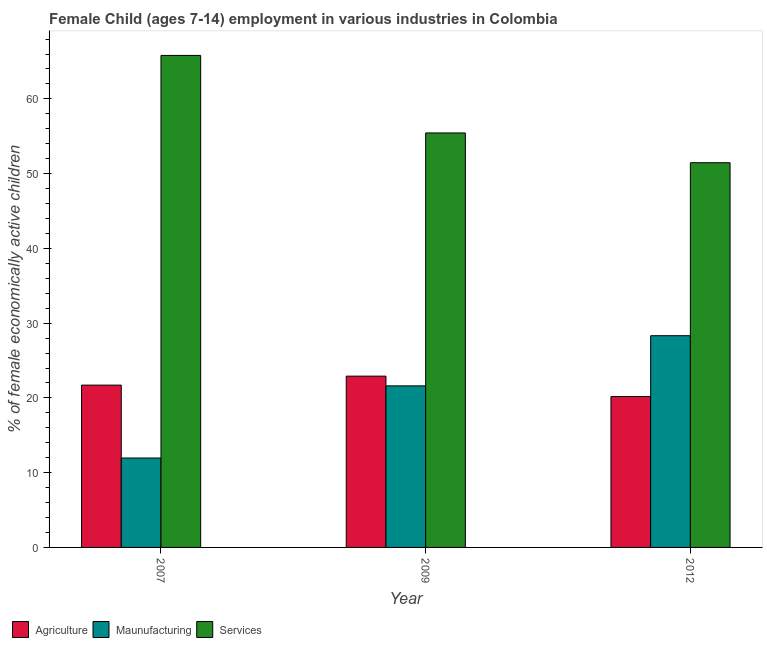How many different coloured bars are there?
Provide a succinct answer. 3. Are the number of bars per tick equal to the number of legend labels?
Your answer should be very brief. Yes. Are the number of bars on each tick of the X-axis equal?
Ensure brevity in your answer.  Yes. How many bars are there on the 1st tick from the left?
Your answer should be very brief. 3. How many bars are there on the 2nd tick from the right?
Make the answer very short. 3. In how many cases, is the number of bars for a given year not equal to the number of legend labels?
Ensure brevity in your answer.  0. What is the percentage of economically active children in services in 2007?
Keep it short and to the point. 65.81. Across all years, what is the maximum percentage of economically active children in manufacturing?
Ensure brevity in your answer.  28.32. Across all years, what is the minimum percentage of economically active children in agriculture?
Give a very brief answer. 20.18. What is the total percentage of economically active children in services in the graph?
Give a very brief answer. 172.71. What is the difference between the percentage of economically active children in agriculture in 2007 and that in 2009?
Keep it short and to the point. -1.2. What is the difference between the percentage of economically active children in manufacturing in 2012 and the percentage of economically active children in agriculture in 2009?
Your answer should be compact. 6.71. What is the average percentage of economically active children in services per year?
Give a very brief answer. 57.57. In the year 2007, what is the difference between the percentage of economically active children in services and percentage of economically active children in manufacturing?
Provide a short and direct response. 0. In how many years, is the percentage of economically active children in manufacturing greater than 56 %?
Provide a succinct answer. 0. What is the ratio of the percentage of economically active children in agriculture in 2007 to that in 2012?
Keep it short and to the point. 1.08. What is the difference between the highest and the second highest percentage of economically active children in services?
Give a very brief answer. 10.37. What is the difference between the highest and the lowest percentage of economically active children in manufacturing?
Your response must be concise. 16.36. What does the 1st bar from the left in 2012 represents?
Provide a short and direct response. Agriculture. What does the 2nd bar from the right in 2007 represents?
Provide a short and direct response. Maunufacturing. How many bars are there?
Make the answer very short. 9. Are all the bars in the graph horizontal?
Ensure brevity in your answer.  No. Are the values on the major ticks of Y-axis written in scientific E-notation?
Ensure brevity in your answer.  No. How many legend labels are there?
Your response must be concise. 3. What is the title of the graph?
Ensure brevity in your answer.  Female Child (ages 7-14) employment in various industries in Colombia. Does "Fuel" appear as one of the legend labels in the graph?
Your answer should be very brief. No. What is the label or title of the X-axis?
Offer a terse response. Year. What is the label or title of the Y-axis?
Keep it short and to the point. % of female economically active children. What is the % of female economically active children in Agriculture in 2007?
Provide a short and direct response. 21.71. What is the % of female economically active children in Maunufacturing in 2007?
Ensure brevity in your answer.  11.96. What is the % of female economically active children in Services in 2007?
Your response must be concise. 65.81. What is the % of female economically active children in Agriculture in 2009?
Offer a terse response. 22.91. What is the % of female economically active children of Maunufacturing in 2009?
Ensure brevity in your answer.  21.61. What is the % of female economically active children in Services in 2009?
Give a very brief answer. 55.44. What is the % of female economically active children of Agriculture in 2012?
Keep it short and to the point. 20.18. What is the % of female economically active children of Maunufacturing in 2012?
Provide a succinct answer. 28.32. What is the % of female economically active children of Services in 2012?
Give a very brief answer. 51.46. Across all years, what is the maximum % of female economically active children of Agriculture?
Your answer should be compact. 22.91. Across all years, what is the maximum % of female economically active children in Maunufacturing?
Offer a terse response. 28.32. Across all years, what is the maximum % of female economically active children of Services?
Make the answer very short. 65.81. Across all years, what is the minimum % of female economically active children in Agriculture?
Your answer should be compact. 20.18. Across all years, what is the minimum % of female economically active children of Maunufacturing?
Keep it short and to the point. 11.96. Across all years, what is the minimum % of female economically active children of Services?
Your response must be concise. 51.46. What is the total % of female economically active children in Agriculture in the graph?
Provide a short and direct response. 64.8. What is the total % of female economically active children of Maunufacturing in the graph?
Keep it short and to the point. 61.89. What is the total % of female economically active children of Services in the graph?
Your answer should be very brief. 172.71. What is the difference between the % of female economically active children of Agriculture in 2007 and that in 2009?
Ensure brevity in your answer.  -1.2. What is the difference between the % of female economically active children in Maunufacturing in 2007 and that in 2009?
Keep it short and to the point. -9.65. What is the difference between the % of female economically active children in Services in 2007 and that in 2009?
Offer a terse response. 10.37. What is the difference between the % of female economically active children in Agriculture in 2007 and that in 2012?
Provide a succinct answer. 1.53. What is the difference between the % of female economically active children in Maunufacturing in 2007 and that in 2012?
Give a very brief answer. -16.36. What is the difference between the % of female economically active children in Services in 2007 and that in 2012?
Offer a very short reply. 14.35. What is the difference between the % of female economically active children of Agriculture in 2009 and that in 2012?
Offer a very short reply. 2.73. What is the difference between the % of female economically active children of Maunufacturing in 2009 and that in 2012?
Your answer should be compact. -6.71. What is the difference between the % of female economically active children in Services in 2009 and that in 2012?
Your response must be concise. 3.98. What is the difference between the % of female economically active children in Agriculture in 2007 and the % of female economically active children in Services in 2009?
Ensure brevity in your answer.  -33.73. What is the difference between the % of female economically active children of Maunufacturing in 2007 and the % of female economically active children of Services in 2009?
Provide a short and direct response. -43.48. What is the difference between the % of female economically active children in Agriculture in 2007 and the % of female economically active children in Maunufacturing in 2012?
Your answer should be compact. -6.61. What is the difference between the % of female economically active children in Agriculture in 2007 and the % of female economically active children in Services in 2012?
Provide a short and direct response. -29.75. What is the difference between the % of female economically active children in Maunufacturing in 2007 and the % of female economically active children in Services in 2012?
Your answer should be compact. -39.5. What is the difference between the % of female economically active children of Agriculture in 2009 and the % of female economically active children of Maunufacturing in 2012?
Ensure brevity in your answer.  -5.41. What is the difference between the % of female economically active children of Agriculture in 2009 and the % of female economically active children of Services in 2012?
Give a very brief answer. -28.55. What is the difference between the % of female economically active children of Maunufacturing in 2009 and the % of female economically active children of Services in 2012?
Ensure brevity in your answer.  -29.85. What is the average % of female economically active children in Agriculture per year?
Provide a short and direct response. 21.6. What is the average % of female economically active children in Maunufacturing per year?
Provide a succinct answer. 20.63. What is the average % of female economically active children of Services per year?
Your response must be concise. 57.57. In the year 2007, what is the difference between the % of female economically active children in Agriculture and % of female economically active children in Maunufacturing?
Offer a terse response. 9.75. In the year 2007, what is the difference between the % of female economically active children in Agriculture and % of female economically active children in Services?
Provide a short and direct response. -44.1. In the year 2007, what is the difference between the % of female economically active children in Maunufacturing and % of female economically active children in Services?
Provide a succinct answer. -53.85. In the year 2009, what is the difference between the % of female economically active children of Agriculture and % of female economically active children of Maunufacturing?
Offer a terse response. 1.3. In the year 2009, what is the difference between the % of female economically active children of Agriculture and % of female economically active children of Services?
Provide a succinct answer. -32.53. In the year 2009, what is the difference between the % of female economically active children in Maunufacturing and % of female economically active children in Services?
Keep it short and to the point. -33.83. In the year 2012, what is the difference between the % of female economically active children in Agriculture and % of female economically active children in Maunufacturing?
Ensure brevity in your answer.  -8.14. In the year 2012, what is the difference between the % of female economically active children in Agriculture and % of female economically active children in Services?
Your answer should be very brief. -31.28. In the year 2012, what is the difference between the % of female economically active children of Maunufacturing and % of female economically active children of Services?
Make the answer very short. -23.14. What is the ratio of the % of female economically active children in Agriculture in 2007 to that in 2009?
Provide a short and direct response. 0.95. What is the ratio of the % of female economically active children of Maunufacturing in 2007 to that in 2009?
Your response must be concise. 0.55. What is the ratio of the % of female economically active children in Services in 2007 to that in 2009?
Make the answer very short. 1.19. What is the ratio of the % of female economically active children in Agriculture in 2007 to that in 2012?
Your answer should be very brief. 1.08. What is the ratio of the % of female economically active children in Maunufacturing in 2007 to that in 2012?
Provide a succinct answer. 0.42. What is the ratio of the % of female economically active children of Services in 2007 to that in 2012?
Your answer should be very brief. 1.28. What is the ratio of the % of female economically active children in Agriculture in 2009 to that in 2012?
Make the answer very short. 1.14. What is the ratio of the % of female economically active children of Maunufacturing in 2009 to that in 2012?
Provide a succinct answer. 0.76. What is the ratio of the % of female economically active children in Services in 2009 to that in 2012?
Your answer should be compact. 1.08. What is the difference between the highest and the second highest % of female economically active children of Maunufacturing?
Provide a short and direct response. 6.71. What is the difference between the highest and the second highest % of female economically active children in Services?
Offer a terse response. 10.37. What is the difference between the highest and the lowest % of female economically active children in Agriculture?
Ensure brevity in your answer.  2.73. What is the difference between the highest and the lowest % of female economically active children in Maunufacturing?
Your response must be concise. 16.36. What is the difference between the highest and the lowest % of female economically active children of Services?
Provide a short and direct response. 14.35. 